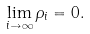Convert formula to latex. <formula><loc_0><loc_0><loc_500><loc_500>\lim _ { i \to \infty } \rho _ { i } = 0 .</formula> 